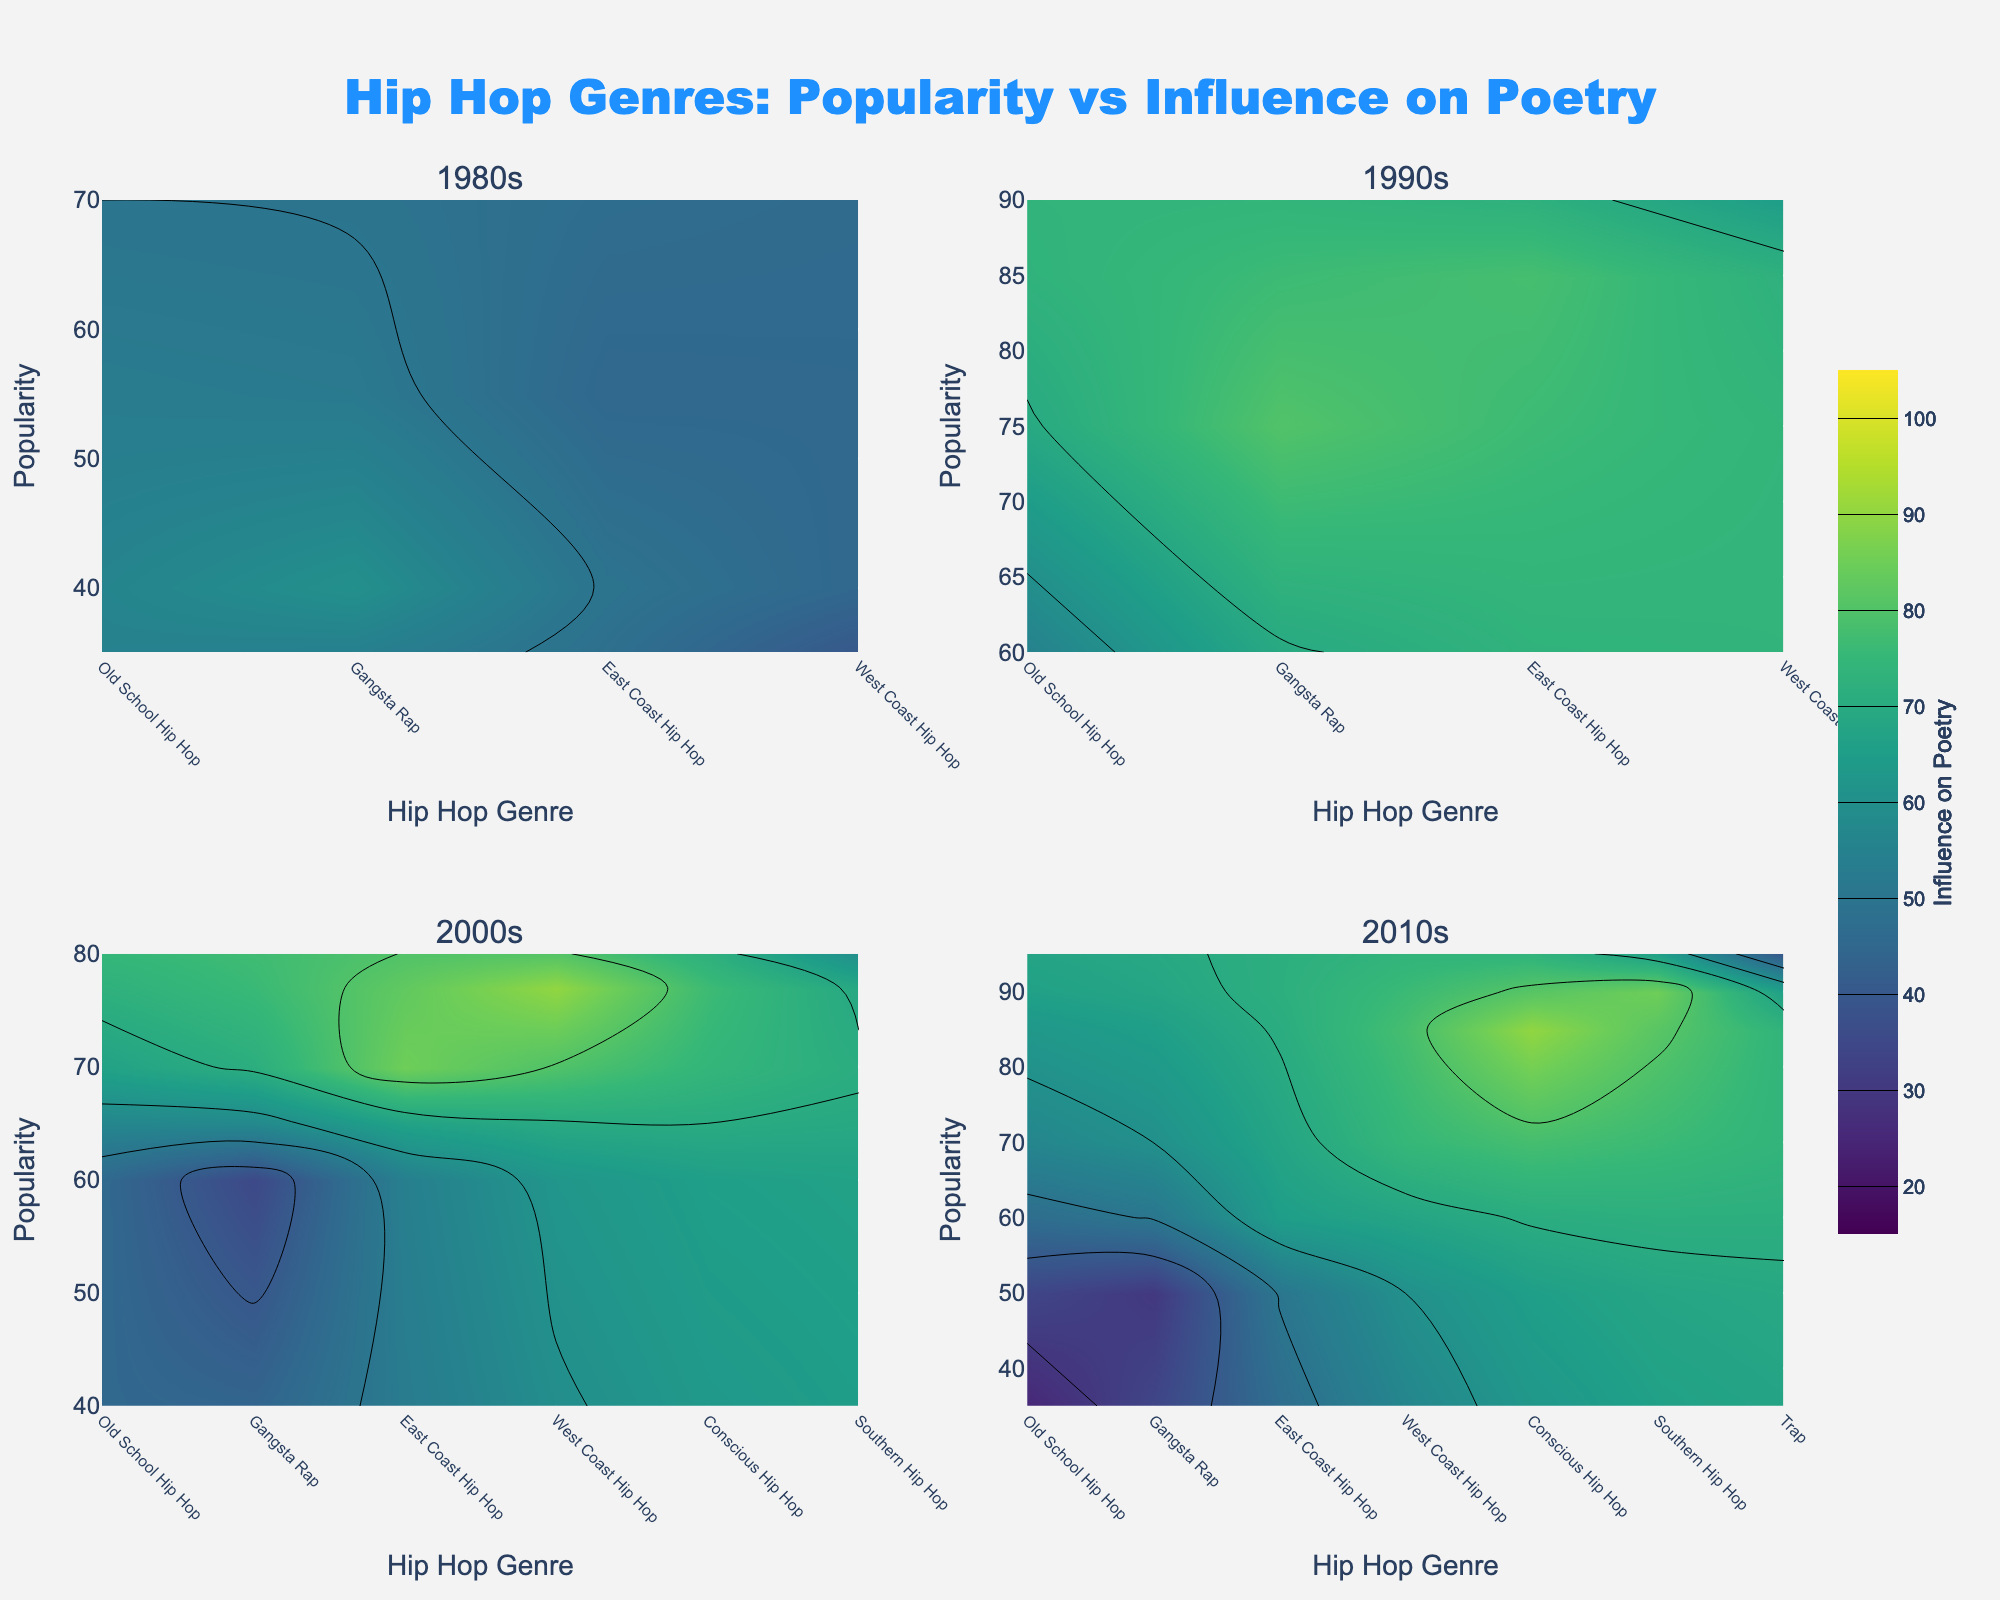What is the title of the figure? The title of the figure is displayed prominently at the top of the plot and is written in a larger font. The background settings and the font details indicate that it is the title of the figure.
Answer: Hip Hop Genres: Popularity vs Influence on Poetry Which decade showcases Conscious Hip Hop reaching its peak in Influence on Poetry? To determine this, look at the subplot titles for each decade and examine the contour plot for Conscious Hip Hop within each decade's subplot. The highest Influence on Poetry value for Conscious Hip Hop is found in the 2010s subplot.
Answer: 2010s In which decade is the genre East Coast Hip Hop most popular? By examining each subplot related to the decades, look at the popularity axis for East Coast Hip Hop. The highest popularity for East Coast Hip Hop is in the 1990s subplot.
Answer: 1990s Compare the popularity of Southern Hip Hop in the 2000s and 2010s. Which decade has higher popularity? Check the popularity values for Southern Hip Hop in both the 2000s and 2010s subplots. Southern Hip Hop has higher popularity in the 2010s.
Answer: 2010s What is the minimum Influence on Poetry for Trap across all decades? Trap appears only in the 2010s subplot. Inspect the Influence on Poetry value for Trap in this subplot; it is 40, which is the minimum value since it only appears in one decade.
Answer: 40 Which genre has the lowest popularity in the 1980s? Refer to the 1980s subplot and compare the popularity values of all genres within that decade. The genre with the lowest popularity is West Coast Hip Hop.
Answer: West Coast Hip Hop How does the Influence on Poetry of Old School Hip Hop change from the 1980s to the 2010s? Old School Hip Hop's Influence on Poetry in the 1980s is 50, while in the 2010s it is 25. To find the change, subtract the 2010s value from the 1980s value: 50 - 25 = 25.
Answer: Decreases by 25 Is the Influence on Poetry for Gangsta Rap higher in the 1990s or the 2000s? Compare the Influence on Poetry values for Gangsta Rap in both the 1990s and 2000s subplots. The 1990s show a higher value of 80 compared to 35 in the 2000s.
Answer: 1990s What is the color scheme used in the figure? The color scheme of the contour plots is observed to be 'Viridis,' which can be noted by the gradient colors used to denote the levels of Influence on Poetry.
Answer: Viridis 